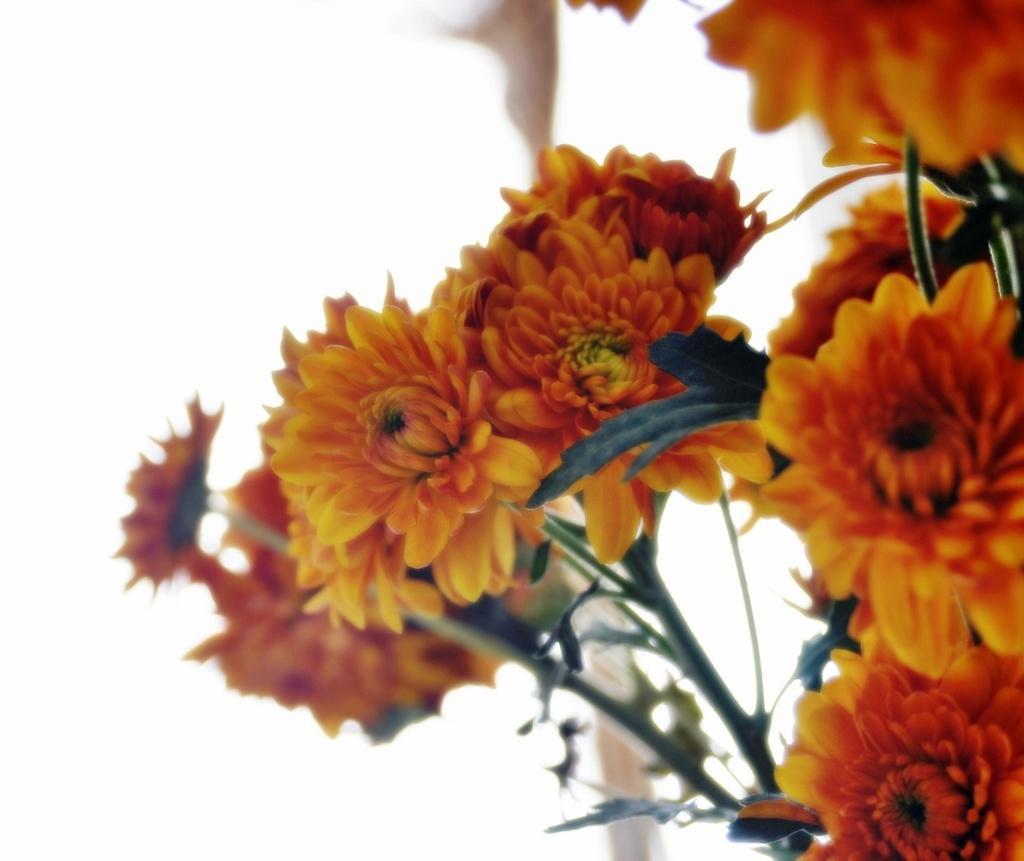Please provide a concise description of this image. In this picture we can see flowers and in the background we can see it is white color. 